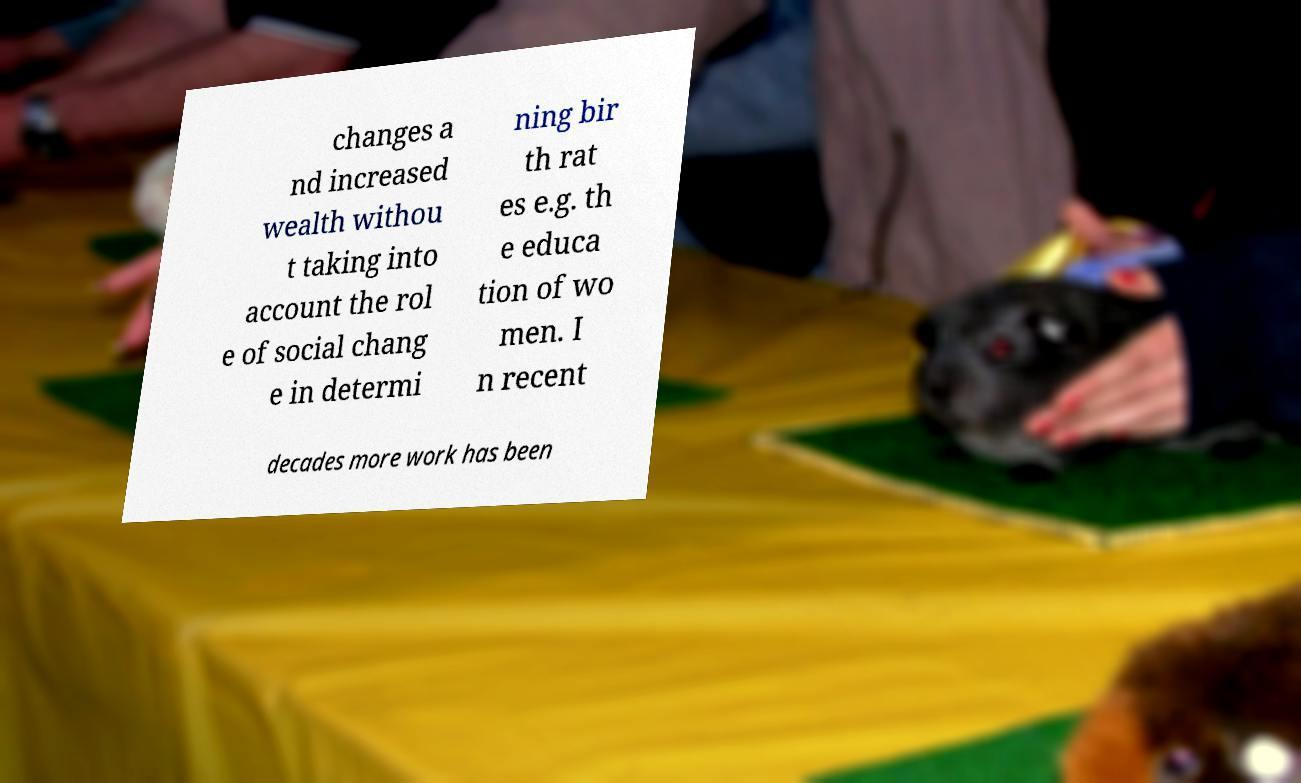Can you read and provide the text displayed in the image?This photo seems to have some interesting text. Can you extract and type it out for me? changes a nd increased wealth withou t taking into account the rol e of social chang e in determi ning bir th rat es e.g. th e educa tion of wo men. I n recent decades more work has been 